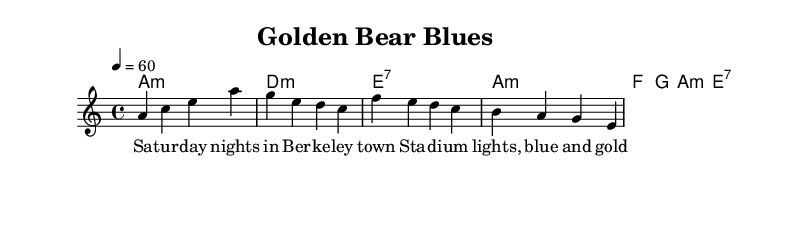What is the key signature of this music? The key signature is A minor, which contains no sharps or flats. This can be seen at the beginning of the score, immediately after the time signature and tempo marking.
Answer: A minor What is the time signature of this music? The time signature is 4/4, which is indicated right after the key signature at the beginning of the piece. This means there are four beats in each measure and the quarter note receives one beat.
Answer: 4/4 What is the tempo marking of this music? The tempo marking is 60 beats per minute, specified in the tempo line as 4 = 60. This indicates the speed at which the piece should be played.
Answer: 60 How many measures are in the verse section? The verse section consists of four measures, as can be noted from the melody line where there are four distinct groupings of notes, separated visually by the bar lines.
Answer: Four Which chord is played in the first measure of the chorus? The chord in the first measure of the chorus is F, indicated above the melody in the chorusChords section. It aligns with the corresponding rhythmic placement of the melody notes.
Answer: F What emotion or sentiment is conveyed in the lyrics of the chorus? The lyrics express nostalgia and a sense of dreaming about college days, as indicated by phrases like "California dreaming" and "college years, they fly by," which reflect on the fleeting nature of those times.
Answer: Nostalgia What type of music is this composition classified as? This composition is classified as Electric Blues, which is characterized by emotional expressions and a blend of traditional blues with electric instruments, as indicated by the chord progressions and structure of the verses and choruses.
Answer: Electric Blues 